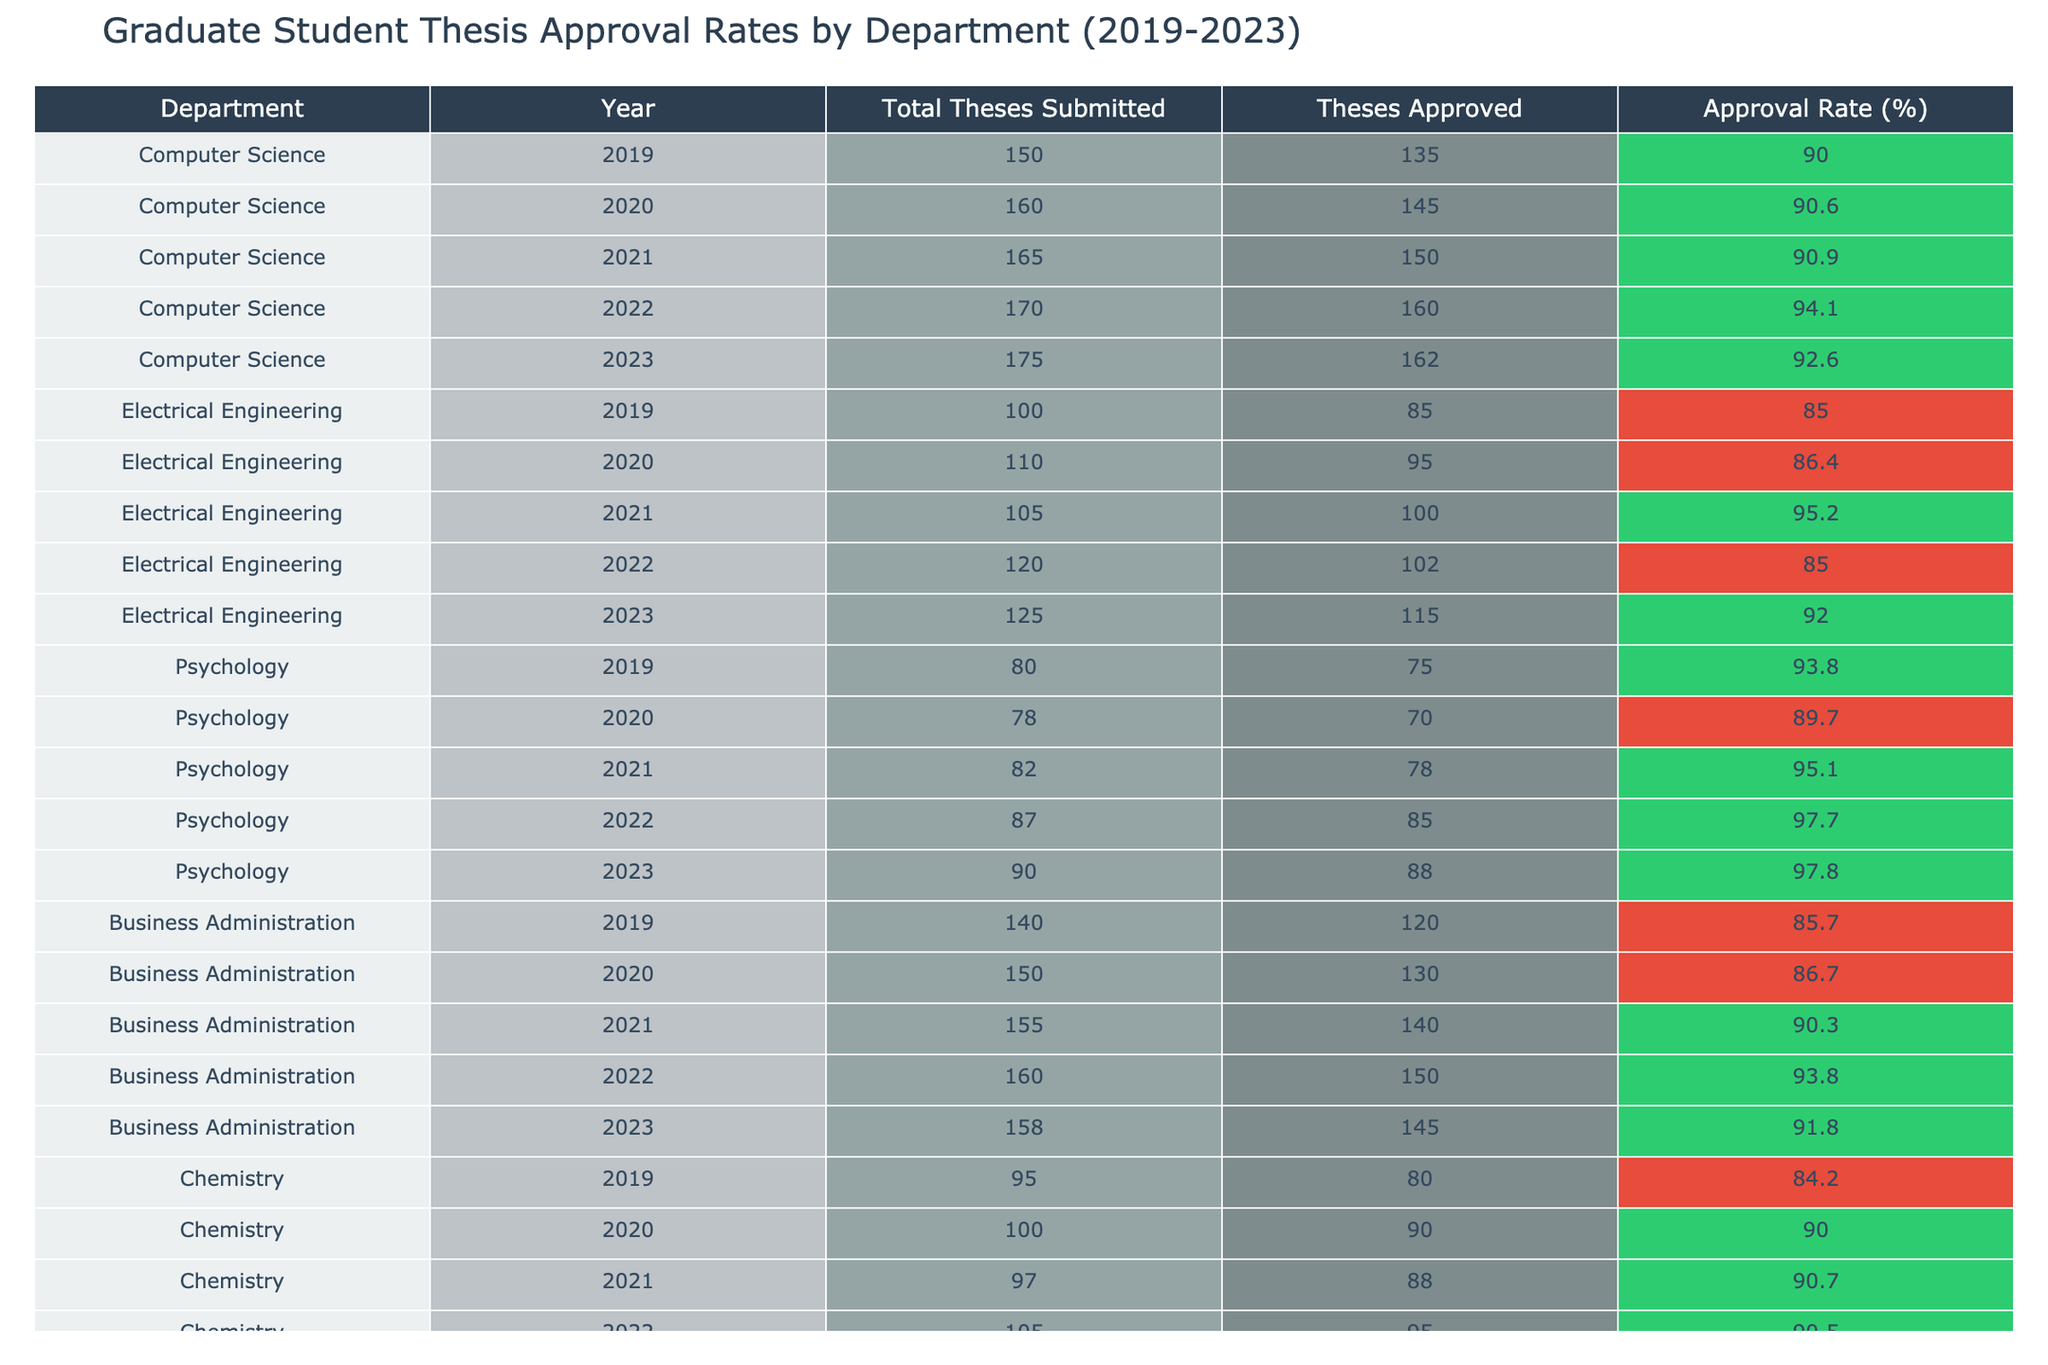What is the approval rate for Computer Science in 2021? In the table, locate the row for the Computer Science department in the year 2021. The approval rate listed for that year is 90.9%
Answer: 90.9% Which department had the highest thesis approval rate in 2023? To determine this, compare the approval rates for all departments in the year 2023. The rates are: Computer Science (92.6%), Electrical Engineering (92.0%), Psychology (97.8%), Business Administration (91.8%), and Chemistry (90.9%). The highest rate is psychology at 97.8%.
Answer: Psychology How many total theses were submitted by the Business Administration department over the five years? Add the total theses submitted from each year for the Business Administration department: 140 + 150 + 155 + 160 + 158 = 763.
Answer: 763 What is the average approval rate for the Electrical Engineering department over the five years? The approval rates for the Electrical Engineering department for the five years are: 85.0%, 86.4%, 95.2%, 85.0%, and 92.0%. To find the average, sum the rates (85.0 + 86.4 + 95.2 + 85.0 + 92.0 = 443.6) and divide by 5. The average is 443.6 / 5 = 88.72%.
Answer: 88.72% Did the Chemistry department have a higher approval rate than 90% in the year 2022? Check the Chemistry department's approval rate for 2022, which is given as 90.5%. Since 90.5% is greater than 90%, the statement is true.
Answer: Yes What is the difference in approval rates between Psychology and Electrical Engineering in 2021? Find the approval rates for 2021: Psychology is 95.1% and Electrical Engineering is 95.2%. The difference is calculated by subtracting Psychology's rate from Electrical Engineering's rate: 95.2 - 95.1 = 0.1%.
Answer: 0.1% 